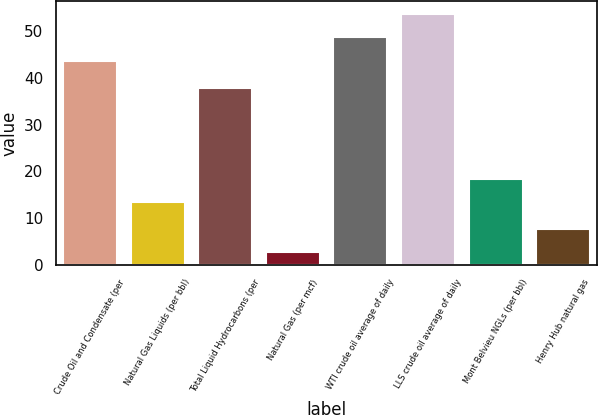<chart> <loc_0><loc_0><loc_500><loc_500><bar_chart><fcel>Crude Oil and Condensate (per<fcel>Natural Gas Liquids (per bbl)<fcel>Total Liquid Hydrocarbons (per<fcel>Natural Gas (per mcf)<fcel>WTI crude oil average of daily<fcel>LLS crude oil average of daily<fcel>Mont Belvieu NGLs (per bbl)<fcel>Henry Hub natural gas<nl><fcel>43.5<fcel>13.37<fcel>37.85<fcel>2.66<fcel>48.76<fcel>53.73<fcel>18.34<fcel>7.63<nl></chart> 